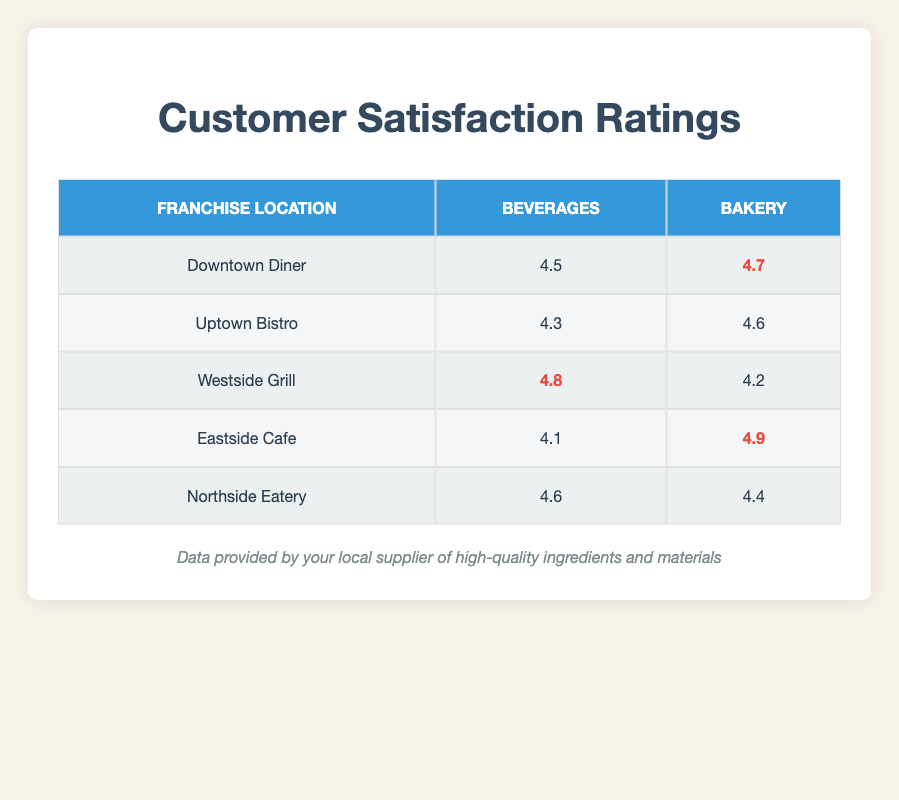What is the customer satisfaction rating for Beverages at the Westside Grill? The table shows that the customer satisfaction rating for Beverages at the Westside Grill is 4.8.
Answer: 4.8 Which location has the highest customer satisfaction rating for Bakery? By comparing the ratings in the Bakery column, Eastside Cafe has the highest rating of 4.9.
Answer: 4.9 Is the customer satisfaction rating for Bakery higher than that for Beverages at Uptown Bistro? The rating for Bakery at Uptown Bistro is 4.6, which is greater than the 4.3 for Beverages, so the statement is true.
Answer: Yes What is the average customer satisfaction rating for Beverages across all locations? The ratings for Beverages are 4.5, 4.3, 4.8, 4.1, and 4.6. Their sum is 4.5 + 4.3 + 4.8 + 4.1 + 4.6 = 22.3. Dividing by 5 gives an average of 22.3 / 5 = 4.46.
Answer: 4.46 Which franchise location has the lowest rating for Beverages? Among the ratings for Beverages, Eastside Cafe at 4.1 has the lowest score compared to other locations.
Answer: Eastside Cafe What is the difference between the highest and lowest customer satisfaction ratings for Bakery? The highest rating for Bakery is 4.9 at Eastside Cafe, and the lowest is 4.2 at Westside Grill. Calculating the difference gives 4.9 - 4.2 = 0.7.
Answer: 0.7 Does Northside Eatery have a lower customer satisfaction rating for Bakery compared to Beverages? Northside Eatery's rating for Beverages is 4.6, while for Bakery it is 4.4. Since 4.4 is lower than 4.6, the statement is true.
Answer: Yes Which product category has a better average customer satisfaction rating across all franchises? For Bakery, the ratings are 4.7, 4.6, 4.2, 4.9, and 4.4, summing to 24.8, giving an average of 24.8 / 5 = 4.96. For Beverages, the ratings are 4.5, 4.3, 4.8, 4.1, and 4.6, summing to 22.3, giving an average of 22.3 / 5 = 4.46. Bakery has a higher average.
Answer: Bakery 